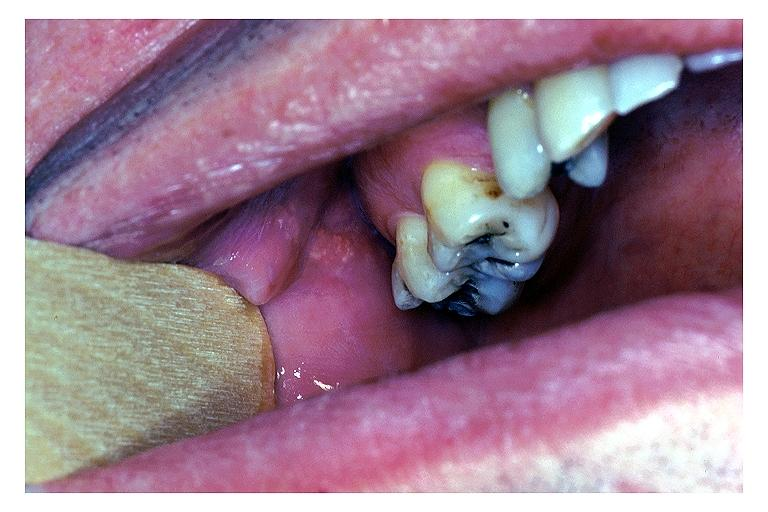where is this?
Answer the question using a single word or phrase. Oral 